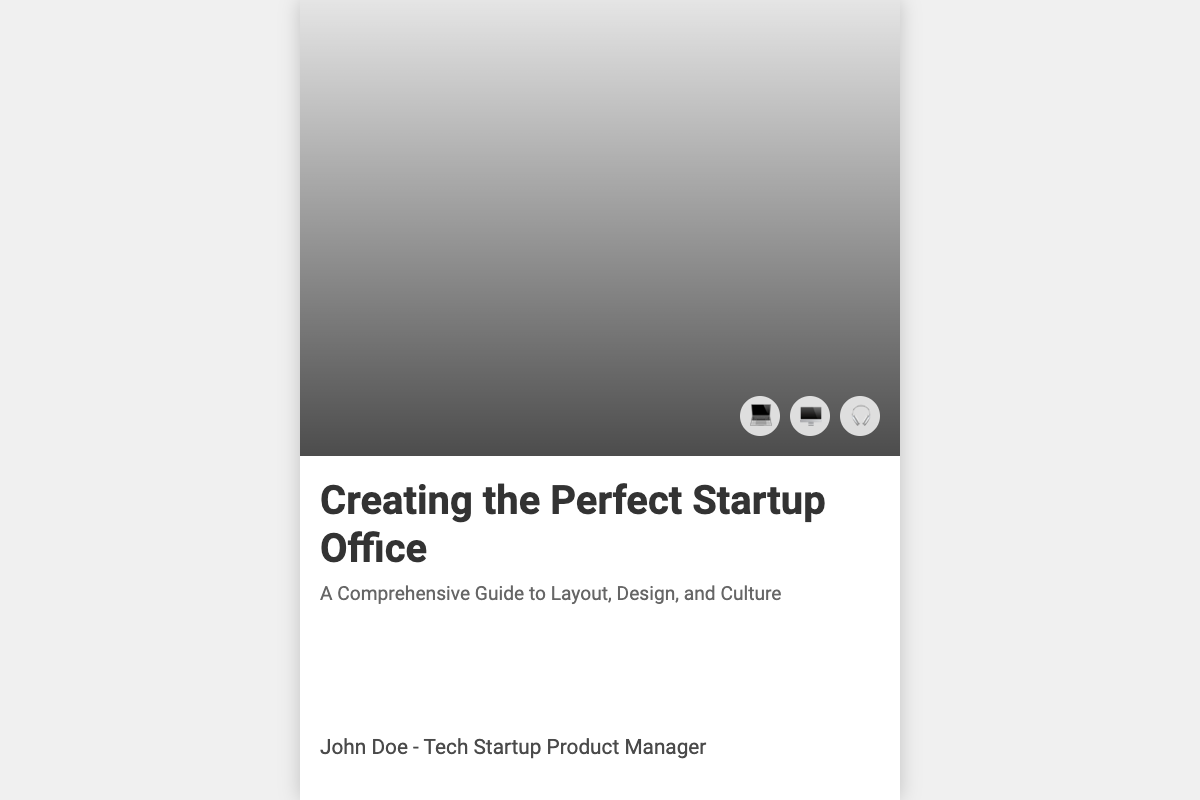what is the main title of the book? The title of the book is prominently displayed at the top of the cover, which is "Creating the Perfect Startup Office."
Answer: Creating the Perfect Startup Office who is the author of the book? The author's name is listed at the bottom of the cover as "John Doe - Tech Startup Product Manager."
Answer: John Doe what percentage of the cover is dedicated to the cover image? The cover image occupies 60% of the total cover area, as indicated by its height in the layout.
Answer: 60% what theme does the subtitle reflect? The subtitle "A Comprehensive Guide to Layout, Design, and Culture" suggests a focus on multiple aspects of creating an office environment.
Answer: Layout, Design, and Culture how many tech icons are displayed on the cover? There are three tech icons included on the cover, representing various gadgets used in modern offices.
Answer: 3 what color theme is used in the book cover design? The overall design features a minimalist color theme primarily using white with shades of gray.
Answer: White and gray what is the function of the overlay on the cover image? The overlay serves to enhance the visibility of the title and icons by providing a gradient background.
Answer: Enhance visibility which type of image is used for the cover? The document specifies the use of a modern, minimalist office image as the background for the cover.
Answer: Modern, minimalist office image what is the main focus of the book as inferred from the title? The title indicates a focus on establishing a suitable and effective office setup for startups.
Answer: Office setup for startups 